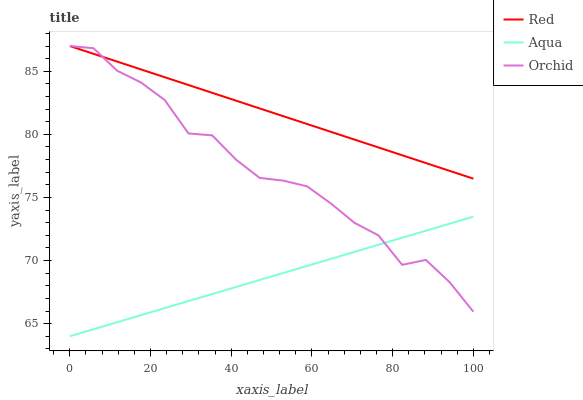Does Aqua have the minimum area under the curve?
Answer yes or no. Yes. Does Red have the maximum area under the curve?
Answer yes or no. Yes. Does Orchid have the minimum area under the curve?
Answer yes or no. No. Does Orchid have the maximum area under the curve?
Answer yes or no. No. Is Aqua the smoothest?
Answer yes or no. Yes. Is Orchid the roughest?
Answer yes or no. Yes. Is Red the smoothest?
Answer yes or no. No. Is Red the roughest?
Answer yes or no. No. Does Aqua have the lowest value?
Answer yes or no. Yes. Does Orchid have the lowest value?
Answer yes or no. No. Does Orchid have the highest value?
Answer yes or no. Yes. Is Aqua less than Red?
Answer yes or no. Yes. Is Red greater than Aqua?
Answer yes or no. Yes. Does Red intersect Orchid?
Answer yes or no. Yes. Is Red less than Orchid?
Answer yes or no. No. Is Red greater than Orchid?
Answer yes or no. No. Does Aqua intersect Red?
Answer yes or no. No. 